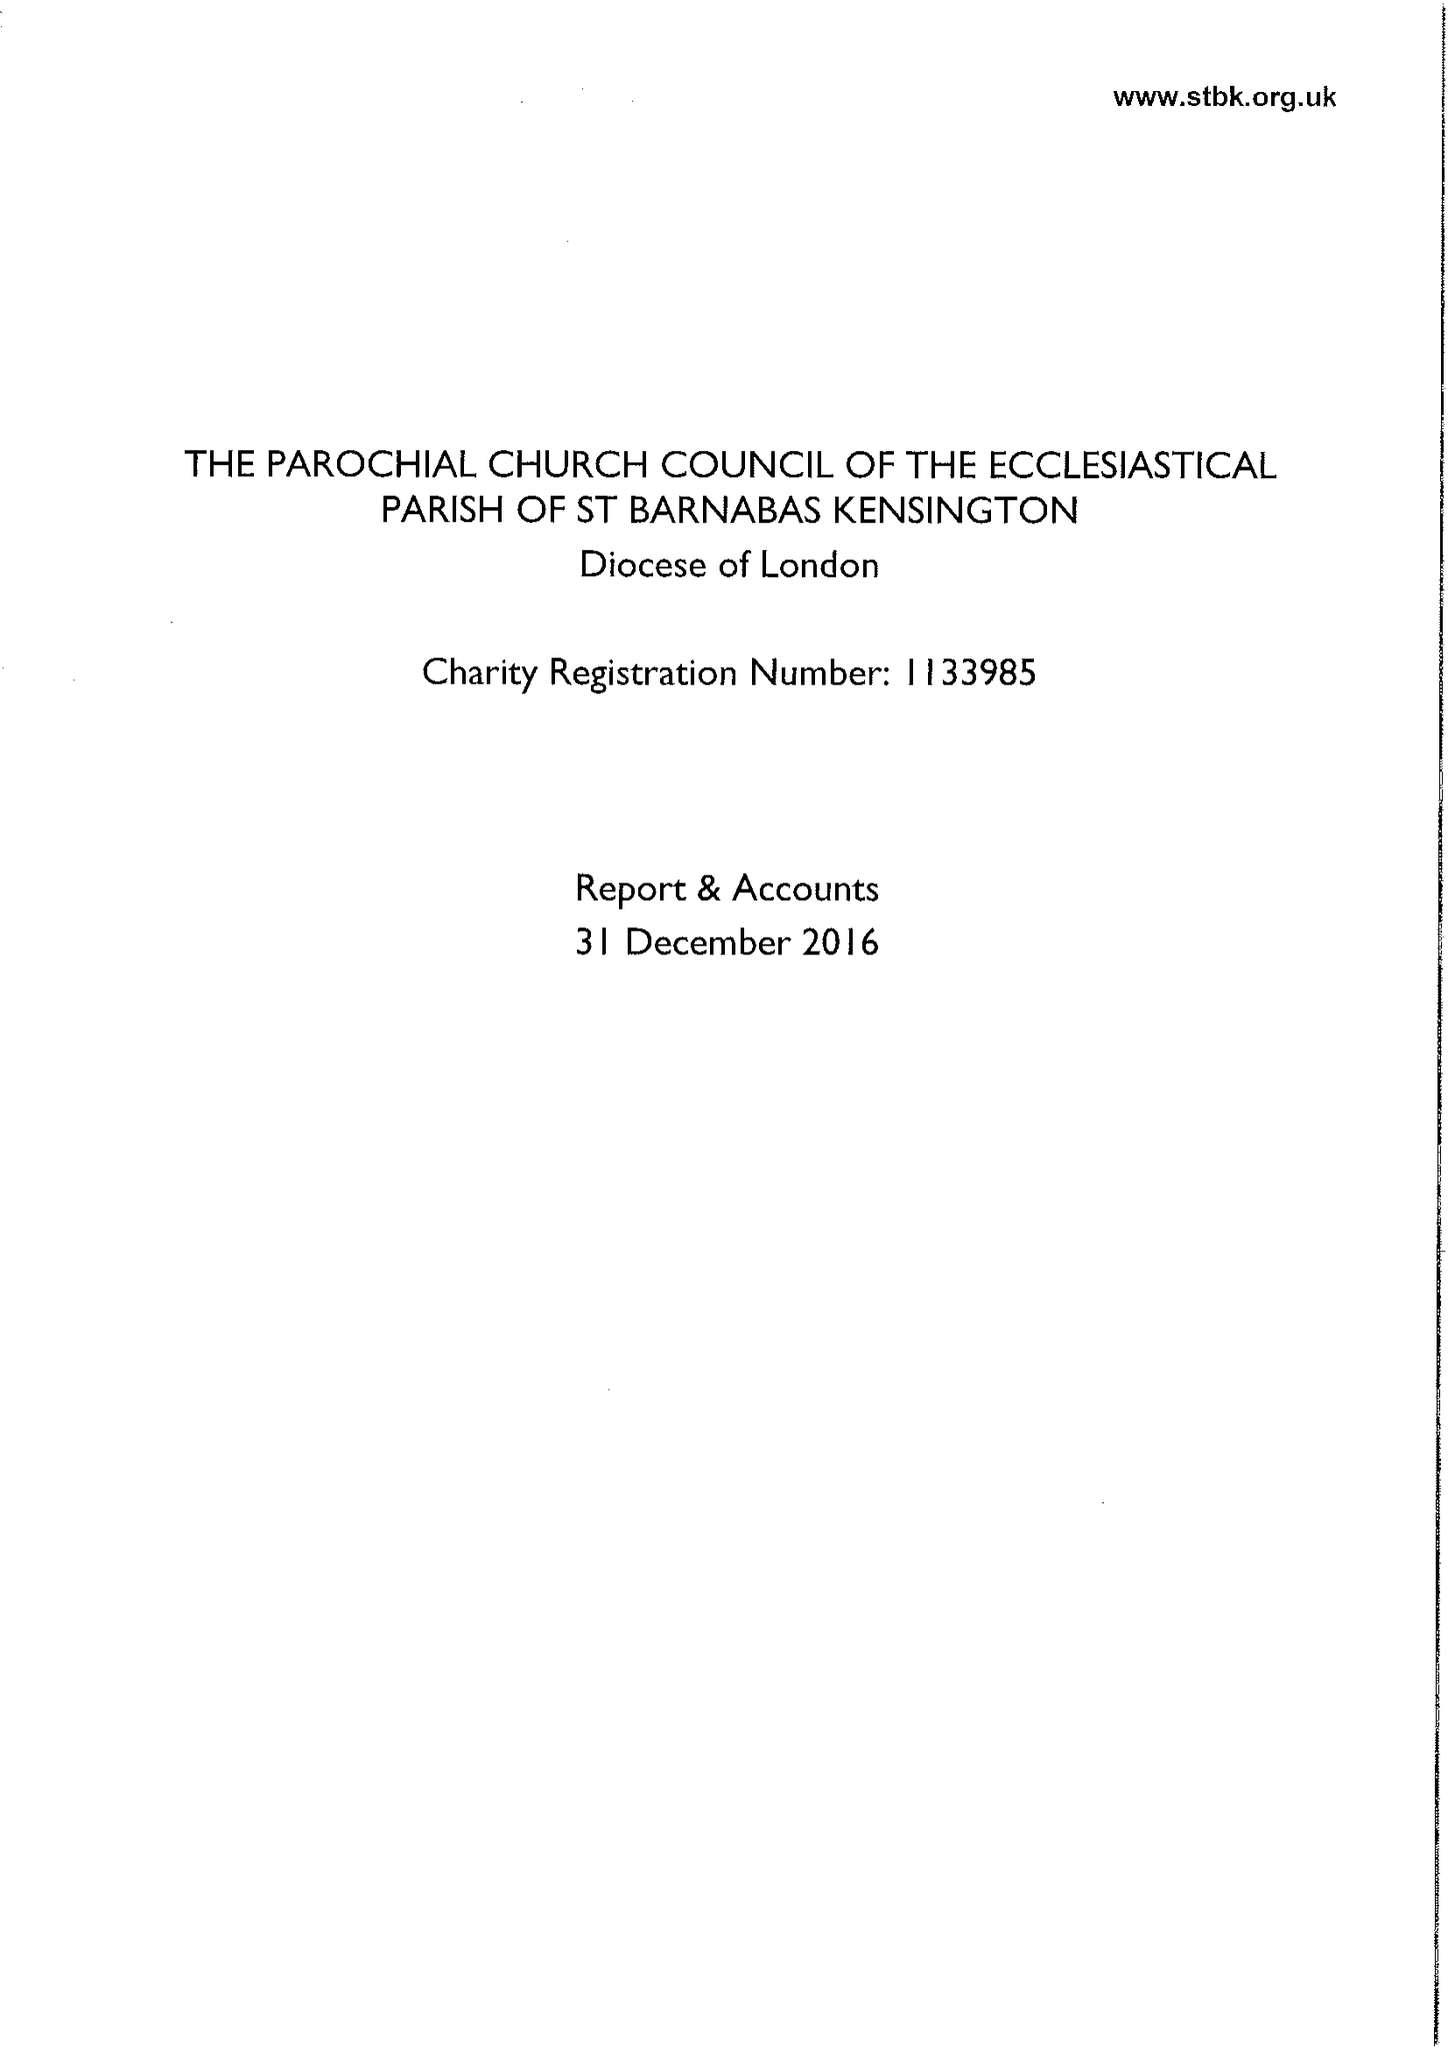What is the value for the charity_number?
Answer the question using a single word or phrase. 1133985 